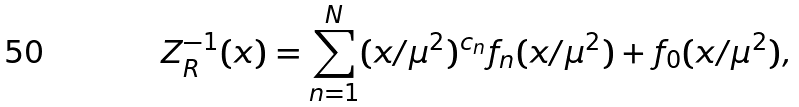<formula> <loc_0><loc_0><loc_500><loc_500>Z _ { R } ^ { - 1 } ( x ) = \sum _ { n = 1 } ^ { N } ( x / \mu ^ { 2 } ) ^ { c _ { n } } f _ { n } ( x / \mu ^ { 2 } ) + f _ { 0 } ( x / \mu ^ { 2 } ) ,</formula> 